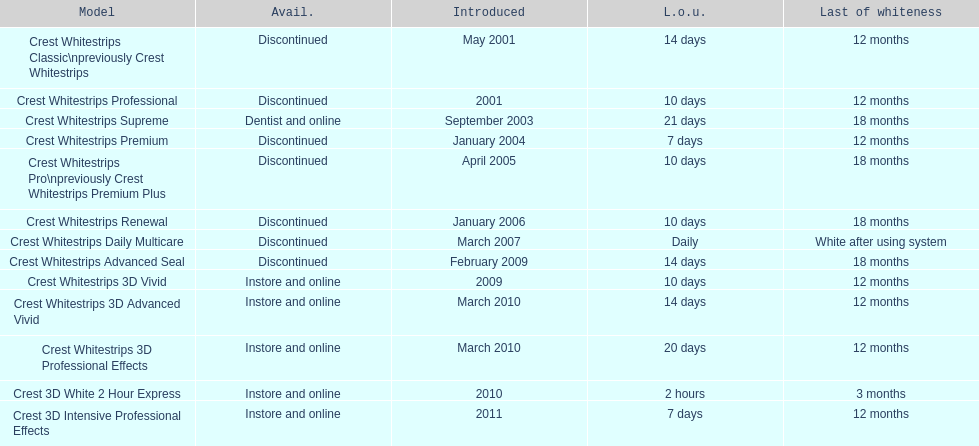Tell me the number of products that give you 12 months of whiteness. 7. Write the full table. {'header': ['Model', 'Avail.', 'Introduced', 'L.o.u.', 'Last of whiteness'], 'rows': [['Crest Whitestrips Classic\\npreviously Crest Whitestrips', 'Discontinued', 'May 2001', '14 days', '12 months'], ['Crest Whitestrips Professional', 'Discontinued', '2001', '10 days', '12 months'], ['Crest Whitestrips Supreme', 'Dentist and online', 'September 2003', '21 days', '18 months'], ['Crest Whitestrips Premium', 'Discontinued', 'January 2004', '7 days', '12 months'], ['Crest Whitestrips Pro\\npreviously Crest Whitestrips Premium Plus', 'Discontinued', 'April 2005', '10 days', '18 months'], ['Crest Whitestrips Renewal', 'Discontinued', 'January 2006', '10 days', '18 months'], ['Crest Whitestrips Daily Multicare', 'Discontinued', 'March 2007', 'Daily', 'White after using system'], ['Crest Whitestrips Advanced Seal', 'Discontinued', 'February 2009', '14 days', '18 months'], ['Crest Whitestrips 3D Vivid', 'Instore and online', '2009', '10 days', '12 months'], ['Crest Whitestrips 3D Advanced Vivid', 'Instore and online', 'March 2010', '14 days', '12 months'], ['Crest Whitestrips 3D Professional Effects', 'Instore and online', 'March 2010', '20 days', '12 months'], ['Crest 3D White 2 Hour Express', 'Instore and online', '2010', '2 hours', '3 months'], ['Crest 3D Intensive Professional Effects', 'Instore and online', '2011', '7 days', '12 months']]} 